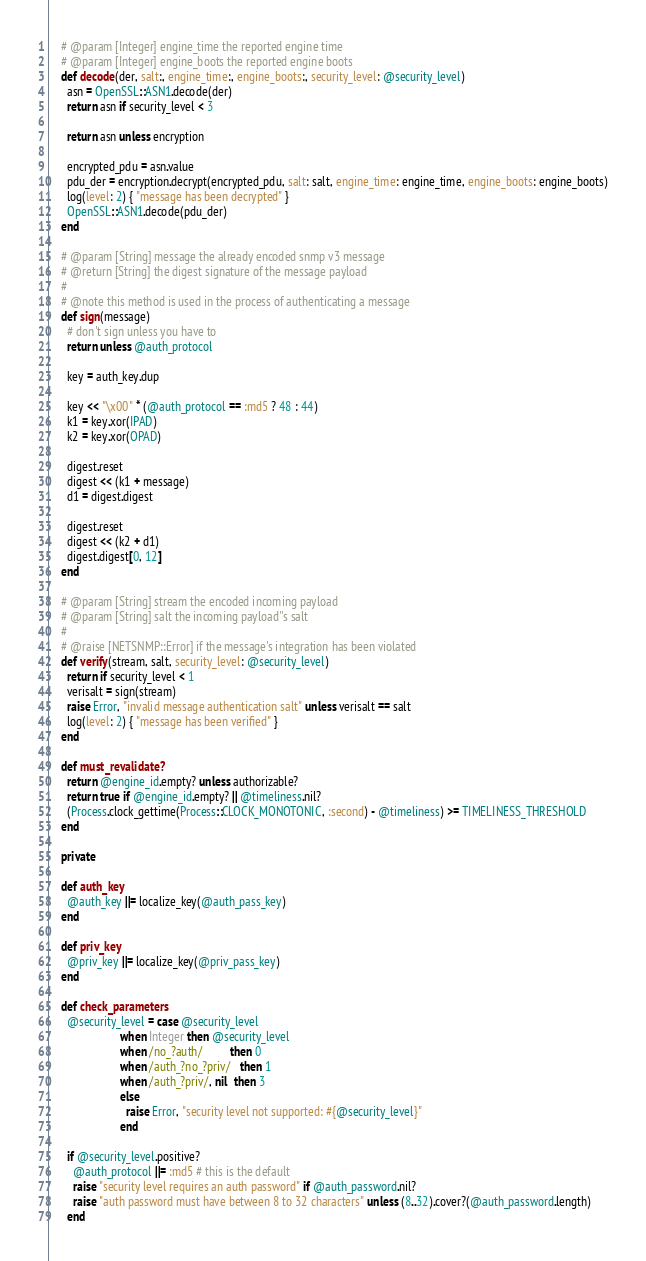<code> <loc_0><loc_0><loc_500><loc_500><_Ruby_>    # @param [Integer] engine_time the reported engine time
    # @param [Integer] engine_boots the reported engine boots
    def decode(der, salt:, engine_time:, engine_boots:, security_level: @security_level)
      asn = OpenSSL::ASN1.decode(der)
      return asn if security_level < 3

      return asn unless encryption

      encrypted_pdu = asn.value
      pdu_der = encryption.decrypt(encrypted_pdu, salt: salt, engine_time: engine_time, engine_boots: engine_boots)
      log(level: 2) { "message has been decrypted" }
      OpenSSL::ASN1.decode(pdu_der)
    end

    # @param [String] message the already encoded snmp v3 message
    # @return [String] the digest signature of the message payload
    #
    # @note this method is used in the process of authenticating a message
    def sign(message)
      # don't sign unless you have to
      return unless @auth_protocol

      key = auth_key.dup

      key << "\x00" * (@auth_protocol == :md5 ? 48 : 44)
      k1 = key.xor(IPAD)
      k2 = key.xor(OPAD)

      digest.reset
      digest << (k1 + message)
      d1 = digest.digest

      digest.reset
      digest << (k2 + d1)
      digest.digest[0, 12]
    end

    # @param [String] stream the encoded incoming payload
    # @param [String] salt the incoming payload''s salt
    #
    # @raise [NETSNMP::Error] if the message's integration has been violated
    def verify(stream, salt, security_level: @security_level)
      return if security_level < 1
      verisalt = sign(stream)
      raise Error, "invalid message authentication salt" unless verisalt == salt
      log(level: 2) { "message has been verified" }
    end

    def must_revalidate?
      return @engine_id.empty? unless authorizable?
      return true if @engine_id.empty? || @timeliness.nil?
      (Process.clock_gettime(Process::CLOCK_MONOTONIC, :second) - @timeliness) >= TIMELINESS_THRESHOLD
    end

    private

    def auth_key
      @auth_key ||= localize_key(@auth_pass_key)
    end

    def priv_key
      @priv_key ||= localize_key(@priv_pass_key)
    end

    def check_parameters
      @security_level = case @security_level
                        when Integer then @security_level
                        when /no_?auth/         then 0
                        when /auth_?no_?priv/   then 1
                        when /auth_?priv/, nil  then 3
                        else
                          raise Error, "security level not supported: #{@security_level}"
                        end

      if @security_level.positive?
        @auth_protocol ||= :md5 # this is the default
        raise "security level requires an auth password" if @auth_password.nil?
        raise "auth password must have between 8 to 32 characters" unless (8..32).cover?(@auth_password.length)
      end</code> 